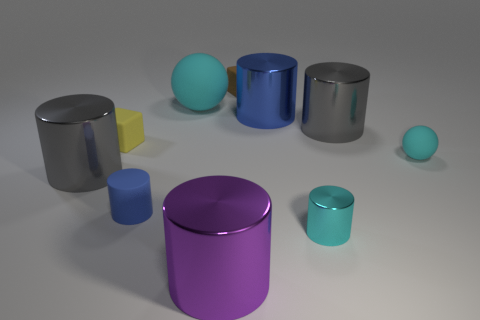What is the color of the matte cylinder that is the same size as the cyan metallic thing?
Give a very brief answer. Blue. Is the large gray cylinder on the left side of the brown block made of the same material as the large purple thing?
Offer a terse response. Yes. What size is the thing that is behind the small cyan rubber ball and to the right of the tiny cyan shiny thing?
Your answer should be very brief. Large. There is a blue object in front of the yellow matte block; what is its size?
Offer a terse response. Small. What shape is the large rubber object that is the same color as the small metallic cylinder?
Provide a succinct answer. Sphere. There is a gray metal object to the right of the cyan ball that is behind the big gray thing that is right of the tiny blue matte cylinder; what is its shape?
Your answer should be very brief. Cylinder. What number of other things are there of the same shape as the large blue thing?
Offer a very short reply. 5. What number of metallic things are either red cubes or cylinders?
Your answer should be very brief. 5. What is the material of the large gray object that is to the right of the large shiny thing to the left of the tiny rubber cylinder?
Keep it short and to the point. Metal. Are there more yellow blocks that are left of the large cyan rubber ball than cyan rubber things?
Your answer should be compact. No. 